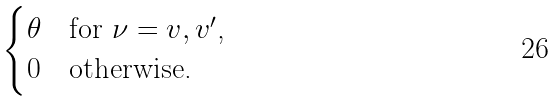Convert formula to latex. <formula><loc_0><loc_0><loc_500><loc_500>\begin{cases} \theta & \text {for $\nu = v,v^{\prime}$,} \\ 0 & \text {otherwise.} \end{cases}</formula> 